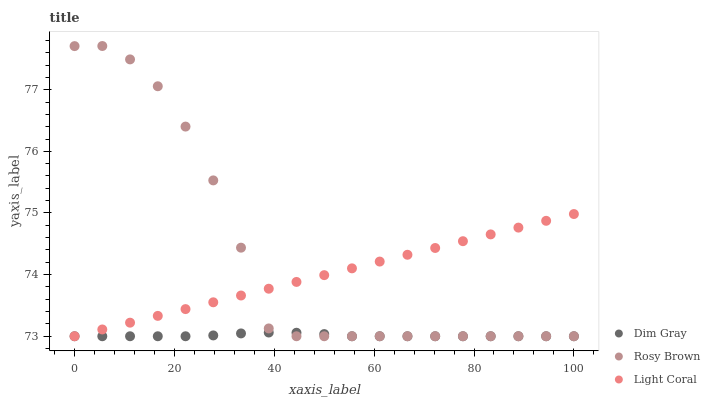Does Dim Gray have the minimum area under the curve?
Answer yes or no. Yes. Does Rosy Brown have the maximum area under the curve?
Answer yes or no. Yes. Does Rosy Brown have the minimum area under the curve?
Answer yes or no. No. Does Dim Gray have the maximum area under the curve?
Answer yes or no. No. Is Light Coral the smoothest?
Answer yes or no. Yes. Is Rosy Brown the roughest?
Answer yes or no. Yes. Is Dim Gray the smoothest?
Answer yes or no. No. Is Dim Gray the roughest?
Answer yes or no. No. Does Light Coral have the lowest value?
Answer yes or no. Yes. Does Rosy Brown have the highest value?
Answer yes or no. Yes. Does Dim Gray have the highest value?
Answer yes or no. No. Does Light Coral intersect Dim Gray?
Answer yes or no. Yes. Is Light Coral less than Dim Gray?
Answer yes or no. No. Is Light Coral greater than Dim Gray?
Answer yes or no. No. 